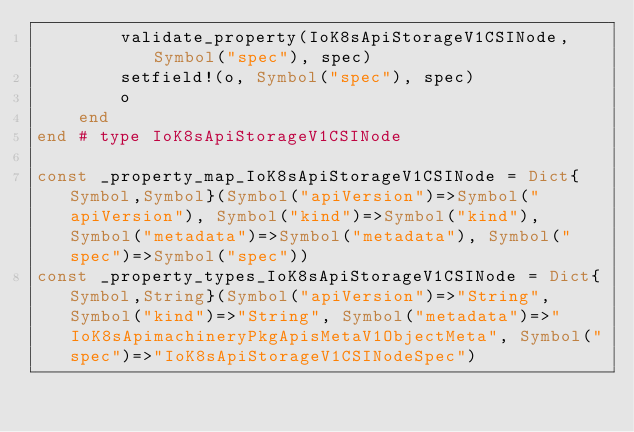Convert code to text. <code><loc_0><loc_0><loc_500><loc_500><_Julia_>        validate_property(IoK8sApiStorageV1CSINode, Symbol("spec"), spec)
        setfield!(o, Symbol("spec"), spec)
        o
    end
end # type IoK8sApiStorageV1CSINode

const _property_map_IoK8sApiStorageV1CSINode = Dict{Symbol,Symbol}(Symbol("apiVersion")=>Symbol("apiVersion"), Symbol("kind")=>Symbol("kind"), Symbol("metadata")=>Symbol("metadata"), Symbol("spec")=>Symbol("spec"))
const _property_types_IoK8sApiStorageV1CSINode = Dict{Symbol,String}(Symbol("apiVersion")=>"String", Symbol("kind")=>"String", Symbol("metadata")=>"IoK8sApimachineryPkgApisMetaV1ObjectMeta", Symbol("spec")=>"IoK8sApiStorageV1CSINodeSpec")</code> 